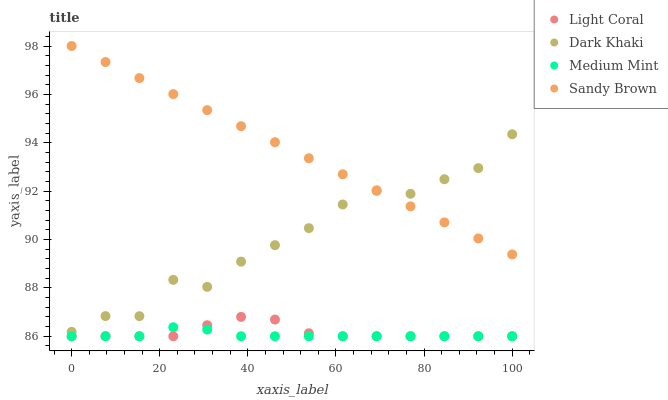Does Medium Mint have the minimum area under the curve?
Answer yes or no. Yes. Does Sandy Brown have the maximum area under the curve?
Answer yes or no. Yes. Does Dark Khaki have the minimum area under the curve?
Answer yes or no. No. Does Dark Khaki have the maximum area under the curve?
Answer yes or no. No. Is Sandy Brown the smoothest?
Answer yes or no. Yes. Is Dark Khaki the roughest?
Answer yes or no. Yes. Is Dark Khaki the smoothest?
Answer yes or no. No. Is Sandy Brown the roughest?
Answer yes or no. No. Does Light Coral have the lowest value?
Answer yes or no. Yes. Does Dark Khaki have the lowest value?
Answer yes or no. No. Does Sandy Brown have the highest value?
Answer yes or no. Yes. Does Dark Khaki have the highest value?
Answer yes or no. No. Is Light Coral less than Sandy Brown?
Answer yes or no. Yes. Is Sandy Brown greater than Medium Mint?
Answer yes or no. Yes. Does Dark Khaki intersect Sandy Brown?
Answer yes or no. Yes. Is Dark Khaki less than Sandy Brown?
Answer yes or no. No. Is Dark Khaki greater than Sandy Brown?
Answer yes or no. No. Does Light Coral intersect Sandy Brown?
Answer yes or no. No. 